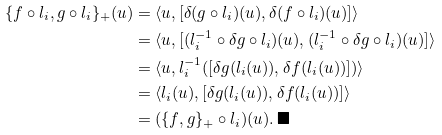Convert formula to latex. <formula><loc_0><loc_0><loc_500><loc_500>\{ f \circ l _ { i } , g \circ l _ { i } \} _ { + } ( u ) & = \langle u , [ \delta ( g \circ l _ { i } ) ( u ) , \delta ( f \circ l _ { i } ) ( u ) ] \rangle \\ & = \langle u , [ ( l _ { i } ^ { - 1 } \circ \delta g \circ l _ { i } ) ( u ) , ( l _ { i } ^ { - 1 } \circ \delta g \circ l _ { i } ) ( u ) ] \rangle \\ & = \langle u , l _ { i } ^ { - 1 } ( [ \delta g ( l _ { i } ( u ) ) , \delta f ( l _ { i } ( u ) ) ] ) \rangle \\ & = \langle l _ { i } ( u ) , [ \delta g ( l _ { i } ( u ) ) , \delta f ( l _ { i } ( u ) ) ] \rangle \\ & = ( \{ f , g \} _ { + } \circ l _ { i } ) ( u ) . \, \blacksquare</formula> 